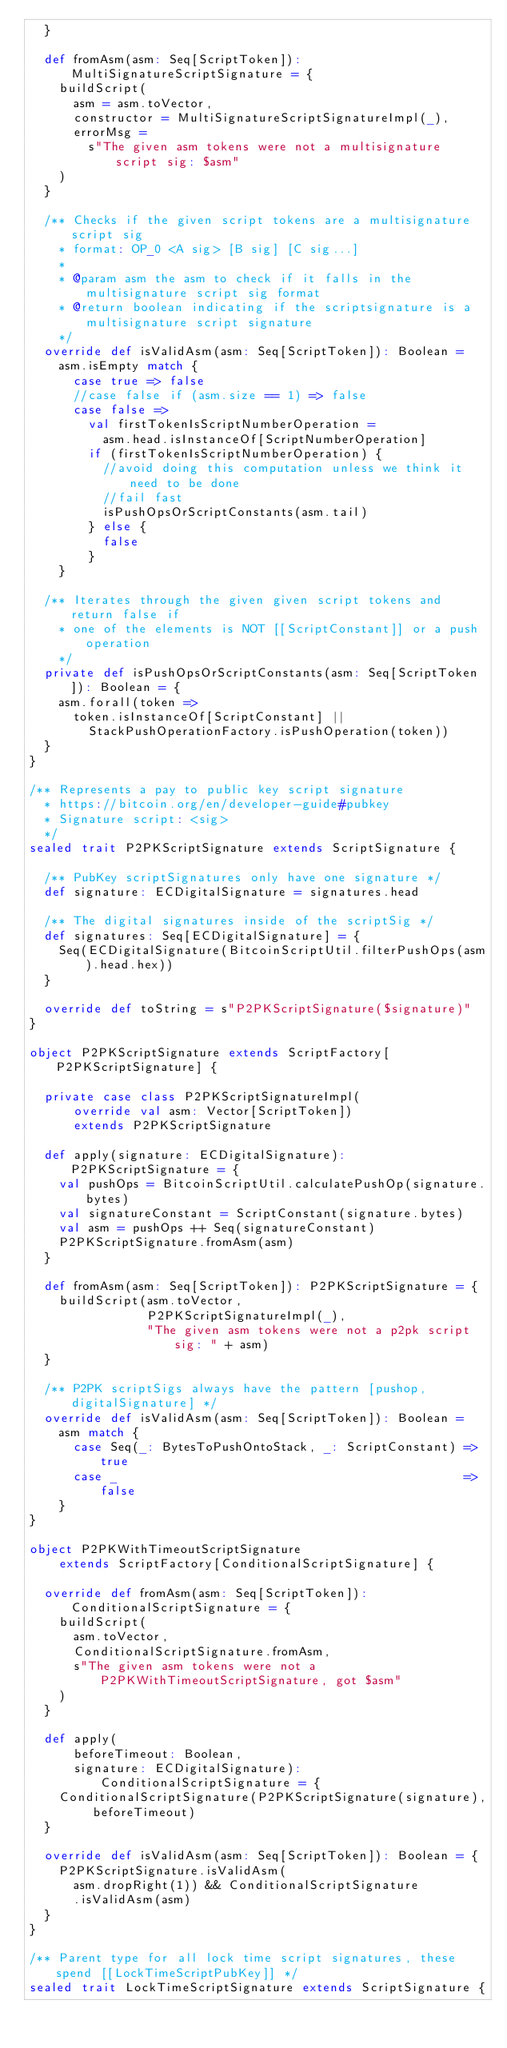<code> <loc_0><loc_0><loc_500><loc_500><_Scala_>  }

  def fromAsm(asm: Seq[ScriptToken]): MultiSignatureScriptSignature = {
    buildScript(
      asm = asm.toVector,
      constructor = MultiSignatureScriptSignatureImpl(_),
      errorMsg =
        s"The given asm tokens were not a multisignature script sig: $asm"
    )
  }

  /** Checks if the given script tokens are a multisignature script sig
    * format: OP_0 <A sig> [B sig] [C sig...]
    *
    * @param asm the asm to check if it falls in the multisignature script sig format
    * @return boolean indicating if the scriptsignature is a multisignature script signature
    */
  override def isValidAsm(asm: Seq[ScriptToken]): Boolean =
    asm.isEmpty match {
      case true => false
      //case false if (asm.size == 1) => false
      case false =>
        val firstTokenIsScriptNumberOperation =
          asm.head.isInstanceOf[ScriptNumberOperation]
        if (firstTokenIsScriptNumberOperation) {
          //avoid doing this computation unless we think it need to be done
          //fail fast
          isPushOpsOrScriptConstants(asm.tail)
        } else {
          false
        }
    }

  /** Iterates through the given given script tokens and return false if
    * one of the elements is NOT [[ScriptConstant]] or a push operation
    */
  private def isPushOpsOrScriptConstants(asm: Seq[ScriptToken]): Boolean = {
    asm.forall(token =>
      token.isInstanceOf[ScriptConstant] ||
        StackPushOperationFactory.isPushOperation(token))
  }
}

/** Represents a pay to public key script signature
  * https://bitcoin.org/en/developer-guide#pubkey
  * Signature script: <sig>
  */
sealed trait P2PKScriptSignature extends ScriptSignature {

  /** PubKey scriptSignatures only have one signature */
  def signature: ECDigitalSignature = signatures.head

  /** The digital signatures inside of the scriptSig */
  def signatures: Seq[ECDigitalSignature] = {
    Seq(ECDigitalSignature(BitcoinScriptUtil.filterPushOps(asm).head.hex))
  }

  override def toString = s"P2PKScriptSignature($signature)"
}

object P2PKScriptSignature extends ScriptFactory[P2PKScriptSignature] {

  private case class P2PKScriptSignatureImpl(
      override val asm: Vector[ScriptToken])
      extends P2PKScriptSignature

  def apply(signature: ECDigitalSignature): P2PKScriptSignature = {
    val pushOps = BitcoinScriptUtil.calculatePushOp(signature.bytes)
    val signatureConstant = ScriptConstant(signature.bytes)
    val asm = pushOps ++ Seq(signatureConstant)
    P2PKScriptSignature.fromAsm(asm)
  }

  def fromAsm(asm: Seq[ScriptToken]): P2PKScriptSignature = {
    buildScript(asm.toVector,
                P2PKScriptSignatureImpl(_),
                "The given asm tokens were not a p2pk script sig: " + asm)
  }

  /** P2PK scriptSigs always have the pattern [pushop, digitalSignature] */
  override def isValidAsm(asm: Seq[ScriptToken]): Boolean =
    asm match {
      case Seq(_: BytesToPushOntoStack, _: ScriptConstant) => true
      case _                                               => false
    }
}

object P2PKWithTimeoutScriptSignature
    extends ScriptFactory[ConditionalScriptSignature] {

  override def fromAsm(asm: Seq[ScriptToken]): ConditionalScriptSignature = {
    buildScript(
      asm.toVector,
      ConditionalScriptSignature.fromAsm,
      s"The given asm tokens were not a P2PKWithTimeoutScriptSignature, got $asm"
    )
  }

  def apply(
      beforeTimeout: Boolean,
      signature: ECDigitalSignature): ConditionalScriptSignature = {
    ConditionalScriptSignature(P2PKScriptSignature(signature), beforeTimeout)
  }

  override def isValidAsm(asm: Seq[ScriptToken]): Boolean = {
    P2PKScriptSignature.isValidAsm(
      asm.dropRight(1)) && ConditionalScriptSignature
      .isValidAsm(asm)
  }
}

/** Parent type for all lock time script signatures, these spend [[LockTimeScriptPubKey]] */
sealed trait LockTimeScriptSignature extends ScriptSignature {</code> 